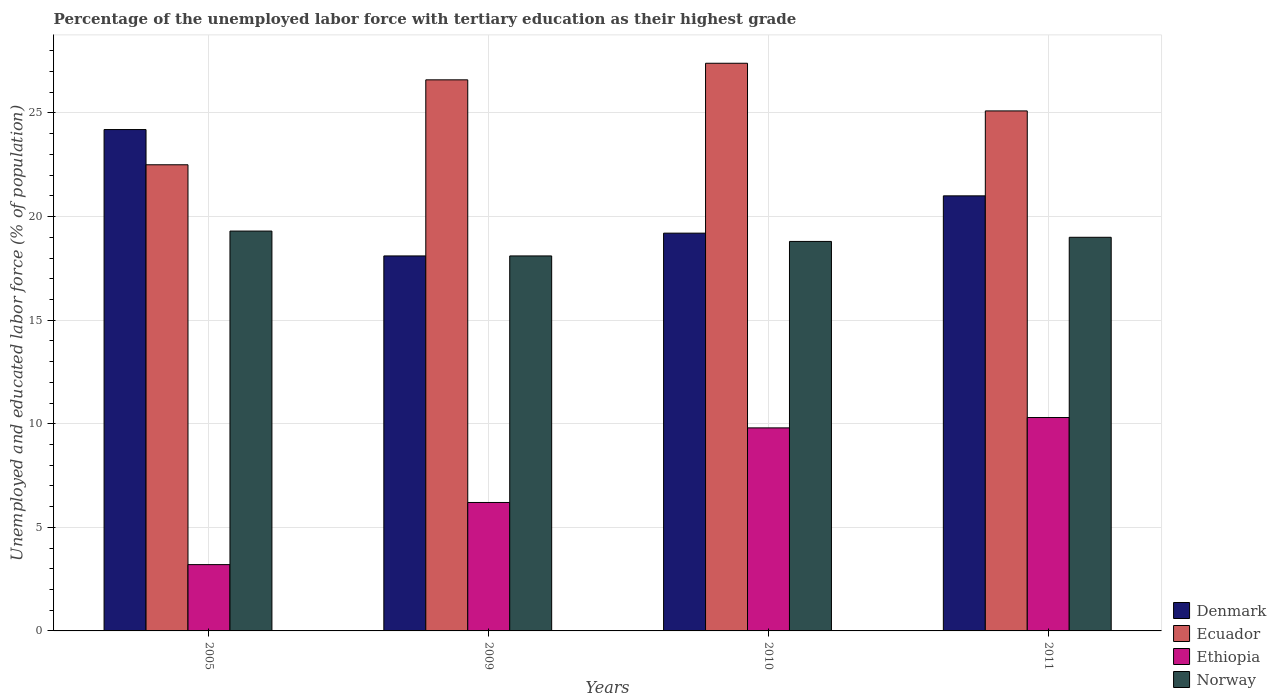How many groups of bars are there?
Offer a very short reply. 4. Are the number of bars on each tick of the X-axis equal?
Keep it short and to the point. Yes. How many bars are there on the 3rd tick from the right?
Your answer should be very brief. 4. What is the percentage of the unemployed labor force with tertiary education in Denmark in 2005?
Offer a terse response. 24.2. Across all years, what is the maximum percentage of the unemployed labor force with tertiary education in Ecuador?
Provide a short and direct response. 27.4. Across all years, what is the minimum percentage of the unemployed labor force with tertiary education in Norway?
Offer a terse response. 18.1. In which year was the percentage of the unemployed labor force with tertiary education in Norway minimum?
Your answer should be very brief. 2009. What is the total percentage of the unemployed labor force with tertiary education in Denmark in the graph?
Ensure brevity in your answer.  82.5. What is the difference between the percentage of the unemployed labor force with tertiary education in Ecuador in 2010 and the percentage of the unemployed labor force with tertiary education in Ethiopia in 2009?
Your answer should be compact. 21.2. What is the average percentage of the unemployed labor force with tertiary education in Ethiopia per year?
Provide a short and direct response. 7.38. In the year 2005, what is the difference between the percentage of the unemployed labor force with tertiary education in Denmark and percentage of the unemployed labor force with tertiary education in Ethiopia?
Provide a short and direct response. 21. What is the ratio of the percentage of the unemployed labor force with tertiary education in Ethiopia in 2010 to that in 2011?
Your answer should be very brief. 0.95. Is the difference between the percentage of the unemployed labor force with tertiary education in Denmark in 2010 and 2011 greater than the difference between the percentage of the unemployed labor force with tertiary education in Ethiopia in 2010 and 2011?
Keep it short and to the point. No. What is the difference between the highest and the second highest percentage of the unemployed labor force with tertiary education in Ethiopia?
Keep it short and to the point. 0.5. What is the difference between the highest and the lowest percentage of the unemployed labor force with tertiary education in Ecuador?
Make the answer very short. 4.9. What does the 2nd bar from the left in 2010 represents?
Give a very brief answer. Ecuador. What does the 3rd bar from the right in 2011 represents?
Make the answer very short. Ecuador. Is it the case that in every year, the sum of the percentage of the unemployed labor force with tertiary education in Denmark and percentage of the unemployed labor force with tertiary education in Norway is greater than the percentage of the unemployed labor force with tertiary education in Ethiopia?
Provide a short and direct response. Yes. How many bars are there?
Provide a short and direct response. 16. Are all the bars in the graph horizontal?
Your answer should be compact. No. How many years are there in the graph?
Provide a succinct answer. 4. What is the difference between two consecutive major ticks on the Y-axis?
Ensure brevity in your answer.  5. Are the values on the major ticks of Y-axis written in scientific E-notation?
Provide a succinct answer. No. Does the graph contain grids?
Offer a very short reply. Yes. Where does the legend appear in the graph?
Ensure brevity in your answer.  Bottom right. How many legend labels are there?
Offer a very short reply. 4. What is the title of the graph?
Make the answer very short. Percentage of the unemployed labor force with tertiary education as their highest grade. What is the label or title of the X-axis?
Make the answer very short. Years. What is the label or title of the Y-axis?
Your response must be concise. Unemployed and educated labor force (% of population). What is the Unemployed and educated labor force (% of population) in Denmark in 2005?
Provide a succinct answer. 24.2. What is the Unemployed and educated labor force (% of population) of Ecuador in 2005?
Offer a very short reply. 22.5. What is the Unemployed and educated labor force (% of population) of Ethiopia in 2005?
Your answer should be very brief. 3.2. What is the Unemployed and educated labor force (% of population) of Norway in 2005?
Provide a succinct answer. 19.3. What is the Unemployed and educated labor force (% of population) of Denmark in 2009?
Make the answer very short. 18.1. What is the Unemployed and educated labor force (% of population) in Ecuador in 2009?
Give a very brief answer. 26.6. What is the Unemployed and educated labor force (% of population) in Ethiopia in 2009?
Offer a very short reply. 6.2. What is the Unemployed and educated labor force (% of population) in Norway in 2009?
Offer a very short reply. 18.1. What is the Unemployed and educated labor force (% of population) of Denmark in 2010?
Offer a very short reply. 19.2. What is the Unemployed and educated labor force (% of population) of Ecuador in 2010?
Offer a very short reply. 27.4. What is the Unemployed and educated labor force (% of population) of Ethiopia in 2010?
Provide a short and direct response. 9.8. What is the Unemployed and educated labor force (% of population) of Norway in 2010?
Provide a succinct answer. 18.8. What is the Unemployed and educated labor force (% of population) in Denmark in 2011?
Offer a terse response. 21. What is the Unemployed and educated labor force (% of population) of Ecuador in 2011?
Provide a succinct answer. 25.1. What is the Unemployed and educated labor force (% of population) of Ethiopia in 2011?
Ensure brevity in your answer.  10.3. What is the Unemployed and educated labor force (% of population) of Norway in 2011?
Make the answer very short. 19. Across all years, what is the maximum Unemployed and educated labor force (% of population) in Denmark?
Your answer should be compact. 24.2. Across all years, what is the maximum Unemployed and educated labor force (% of population) of Ecuador?
Offer a very short reply. 27.4. Across all years, what is the maximum Unemployed and educated labor force (% of population) in Ethiopia?
Make the answer very short. 10.3. Across all years, what is the maximum Unemployed and educated labor force (% of population) in Norway?
Ensure brevity in your answer.  19.3. Across all years, what is the minimum Unemployed and educated labor force (% of population) in Denmark?
Ensure brevity in your answer.  18.1. Across all years, what is the minimum Unemployed and educated labor force (% of population) in Ethiopia?
Offer a terse response. 3.2. Across all years, what is the minimum Unemployed and educated labor force (% of population) in Norway?
Offer a very short reply. 18.1. What is the total Unemployed and educated labor force (% of population) of Denmark in the graph?
Provide a succinct answer. 82.5. What is the total Unemployed and educated labor force (% of population) of Ecuador in the graph?
Ensure brevity in your answer.  101.6. What is the total Unemployed and educated labor force (% of population) of Ethiopia in the graph?
Give a very brief answer. 29.5. What is the total Unemployed and educated labor force (% of population) in Norway in the graph?
Make the answer very short. 75.2. What is the difference between the Unemployed and educated labor force (% of population) of Ecuador in 2005 and that in 2009?
Provide a short and direct response. -4.1. What is the difference between the Unemployed and educated labor force (% of population) in Ethiopia in 2005 and that in 2009?
Ensure brevity in your answer.  -3. What is the difference between the Unemployed and educated labor force (% of population) of Denmark in 2005 and that in 2010?
Keep it short and to the point. 5. What is the difference between the Unemployed and educated labor force (% of population) of Ecuador in 2005 and that in 2010?
Your answer should be compact. -4.9. What is the difference between the Unemployed and educated labor force (% of population) in Denmark in 2005 and that in 2011?
Your answer should be very brief. 3.2. What is the difference between the Unemployed and educated labor force (% of population) in Ecuador in 2005 and that in 2011?
Provide a short and direct response. -2.6. What is the difference between the Unemployed and educated labor force (% of population) of Ethiopia in 2005 and that in 2011?
Your response must be concise. -7.1. What is the difference between the Unemployed and educated labor force (% of population) of Ecuador in 2009 and that in 2010?
Your answer should be very brief. -0.8. What is the difference between the Unemployed and educated labor force (% of population) in Ethiopia in 2009 and that in 2011?
Offer a very short reply. -4.1. What is the difference between the Unemployed and educated labor force (% of population) in Denmark in 2010 and that in 2011?
Your answer should be very brief. -1.8. What is the difference between the Unemployed and educated labor force (% of population) of Norway in 2010 and that in 2011?
Ensure brevity in your answer.  -0.2. What is the difference between the Unemployed and educated labor force (% of population) of Denmark in 2005 and the Unemployed and educated labor force (% of population) of Ethiopia in 2009?
Your response must be concise. 18. What is the difference between the Unemployed and educated labor force (% of population) in Ecuador in 2005 and the Unemployed and educated labor force (% of population) in Ethiopia in 2009?
Provide a short and direct response. 16.3. What is the difference between the Unemployed and educated labor force (% of population) in Ecuador in 2005 and the Unemployed and educated labor force (% of population) in Norway in 2009?
Your answer should be very brief. 4.4. What is the difference between the Unemployed and educated labor force (% of population) of Ethiopia in 2005 and the Unemployed and educated labor force (% of population) of Norway in 2009?
Keep it short and to the point. -14.9. What is the difference between the Unemployed and educated labor force (% of population) of Denmark in 2005 and the Unemployed and educated labor force (% of population) of Norway in 2010?
Provide a short and direct response. 5.4. What is the difference between the Unemployed and educated labor force (% of population) of Ecuador in 2005 and the Unemployed and educated labor force (% of population) of Norway in 2010?
Provide a short and direct response. 3.7. What is the difference between the Unemployed and educated labor force (% of population) of Ethiopia in 2005 and the Unemployed and educated labor force (% of population) of Norway in 2010?
Your answer should be very brief. -15.6. What is the difference between the Unemployed and educated labor force (% of population) in Denmark in 2005 and the Unemployed and educated labor force (% of population) in Ethiopia in 2011?
Your answer should be very brief. 13.9. What is the difference between the Unemployed and educated labor force (% of population) in Ecuador in 2005 and the Unemployed and educated labor force (% of population) in Ethiopia in 2011?
Your answer should be compact. 12.2. What is the difference between the Unemployed and educated labor force (% of population) of Ecuador in 2005 and the Unemployed and educated labor force (% of population) of Norway in 2011?
Give a very brief answer. 3.5. What is the difference between the Unemployed and educated labor force (% of population) of Ethiopia in 2005 and the Unemployed and educated labor force (% of population) of Norway in 2011?
Make the answer very short. -15.8. What is the difference between the Unemployed and educated labor force (% of population) of Denmark in 2009 and the Unemployed and educated labor force (% of population) of Ecuador in 2010?
Provide a succinct answer. -9.3. What is the difference between the Unemployed and educated labor force (% of population) of Denmark in 2009 and the Unemployed and educated labor force (% of population) of Norway in 2010?
Make the answer very short. -0.7. What is the difference between the Unemployed and educated labor force (% of population) of Ecuador in 2009 and the Unemployed and educated labor force (% of population) of Norway in 2010?
Your answer should be very brief. 7.8. What is the difference between the Unemployed and educated labor force (% of population) of Ethiopia in 2009 and the Unemployed and educated labor force (% of population) of Norway in 2010?
Offer a very short reply. -12.6. What is the difference between the Unemployed and educated labor force (% of population) of Denmark in 2009 and the Unemployed and educated labor force (% of population) of Ethiopia in 2011?
Offer a very short reply. 7.8. What is the difference between the Unemployed and educated labor force (% of population) in Ecuador in 2009 and the Unemployed and educated labor force (% of population) in Ethiopia in 2011?
Offer a terse response. 16.3. What is the difference between the Unemployed and educated labor force (% of population) of Ethiopia in 2009 and the Unemployed and educated labor force (% of population) of Norway in 2011?
Your answer should be compact. -12.8. What is the difference between the Unemployed and educated labor force (% of population) of Ecuador in 2010 and the Unemployed and educated labor force (% of population) of Ethiopia in 2011?
Keep it short and to the point. 17.1. What is the difference between the Unemployed and educated labor force (% of population) in Ecuador in 2010 and the Unemployed and educated labor force (% of population) in Norway in 2011?
Provide a succinct answer. 8.4. What is the average Unemployed and educated labor force (% of population) in Denmark per year?
Provide a short and direct response. 20.62. What is the average Unemployed and educated labor force (% of population) in Ecuador per year?
Your answer should be very brief. 25.4. What is the average Unemployed and educated labor force (% of population) of Ethiopia per year?
Keep it short and to the point. 7.38. In the year 2005, what is the difference between the Unemployed and educated labor force (% of population) in Denmark and Unemployed and educated labor force (% of population) in Ecuador?
Offer a very short reply. 1.7. In the year 2005, what is the difference between the Unemployed and educated labor force (% of population) of Denmark and Unemployed and educated labor force (% of population) of Ethiopia?
Your answer should be very brief. 21. In the year 2005, what is the difference between the Unemployed and educated labor force (% of population) of Ecuador and Unemployed and educated labor force (% of population) of Ethiopia?
Provide a short and direct response. 19.3. In the year 2005, what is the difference between the Unemployed and educated labor force (% of population) in Ethiopia and Unemployed and educated labor force (% of population) in Norway?
Keep it short and to the point. -16.1. In the year 2009, what is the difference between the Unemployed and educated labor force (% of population) in Denmark and Unemployed and educated labor force (% of population) in Ethiopia?
Offer a very short reply. 11.9. In the year 2009, what is the difference between the Unemployed and educated labor force (% of population) of Denmark and Unemployed and educated labor force (% of population) of Norway?
Give a very brief answer. 0. In the year 2009, what is the difference between the Unemployed and educated labor force (% of population) in Ecuador and Unemployed and educated labor force (% of population) in Ethiopia?
Offer a terse response. 20.4. In the year 2009, what is the difference between the Unemployed and educated labor force (% of population) in Ecuador and Unemployed and educated labor force (% of population) in Norway?
Ensure brevity in your answer.  8.5. In the year 2010, what is the difference between the Unemployed and educated labor force (% of population) in Denmark and Unemployed and educated labor force (% of population) in Ecuador?
Ensure brevity in your answer.  -8.2. In the year 2010, what is the difference between the Unemployed and educated labor force (% of population) in Denmark and Unemployed and educated labor force (% of population) in Ethiopia?
Give a very brief answer. 9.4. In the year 2010, what is the difference between the Unemployed and educated labor force (% of population) in Denmark and Unemployed and educated labor force (% of population) in Norway?
Keep it short and to the point. 0.4. In the year 2010, what is the difference between the Unemployed and educated labor force (% of population) of Ecuador and Unemployed and educated labor force (% of population) of Ethiopia?
Offer a very short reply. 17.6. In the year 2010, what is the difference between the Unemployed and educated labor force (% of population) in Ecuador and Unemployed and educated labor force (% of population) in Norway?
Ensure brevity in your answer.  8.6. In the year 2010, what is the difference between the Unemployed and educated labor force (% of population) of Ethiopia and Unemployed and educated labor force (% of population) of Norway?
Your response must be concise. -9. In the year 2011, what is the difference between the Unemployed and educated labor force (% of population) of Denmark and Unemployed and educated labor force (% of population) of Norway?
Offer a very short reply. 2. What is the ratio of the Unemployed and educated labor force (% of population) of Denmark in 2005 to that in 2009?
Keep it short and to the point. 1.34. What is the ratio of the Unemployed and educated labor force (% of population) of Ecuador in 2005 to that in 2009?
Give a very brief answer. 0.85. What is the ratio of the Unemployed and educated labor force (% of population) in Ethiopia in 2005 to that in 2009?
Keep it short and to the point. 0.52. What is the ratio of the Unemployed and educated labor force (% of population) of Norway in 2005 to that in 2009?
Your answer should be compact. 1.07. What is the ratio of the Unemployed and educated labor force (% of population) of Denmark in 2005 to that in 2010?
Give a very brief answer. 1.26. What is the ratio of the Unemployed and educated labor force (% of population) of Ecuador in 2005 to that in 2010?
Ensure brevity in your answer.  0.82. What is the ratio of the Unemployed and educated labor force (% of population) of Ethiopia in 2005 to that in 2010?
Offer a very short reply. 0.33. What is the ratio of the Unemployed and educated labor force (% of population) in Norway in 2005 to that in 2010?
Offer a very short reply. 1.03. What is the ratio of the Unemployed and educated labor force (% of population) in Denmark in 2005 to that in 2011?
Make the answer very short. 1.15. What is the ratio of the Unemployed and educated labor force (% of population) of Ecuador in 2005 to that in 2011?
Ensure brevity in your answer.  0.9. What is the ratio of the Unemployed and educated labor force (% of population) in Ethiopia in 2005 to that in 2011?
Keep it short and to the point. 0.31. What is the ratio of the Unemployed and educated labor force (% of population) of Norway in 2005 to that in 2011?
Provide a succinct answer. 1.02. What is the ratio of the Unemployed and educated labor force (% of population) of Denmark in 2009 to that in 2010?
Ensure brevity in your answer.  0.94. What is the ratio of the Unemployed and educated labor force (% of population) in Ecuador in 2009 to that in 2010?
Keep it short and to the point. 0.97. What is the ratio of the Unemployed and educated labor force (% of population) of Ethiopia in 2009 to that in 2010?
Your answer should be compact. 0.63. What is the ratio of the Unemployed and educated labor force (% of population) in Norway in 2009 to that in 2010?
Your answer should be very brief. 0.96. What is the ratio of the Unemployed and educated labor force (% of population) in Denmark in 2009 to that in 2011?
Make the answer very short. 0.86. What is the ratio of the Unemployed and educated labor force (% of population) in Ecuador in 2009 to that in 2011?
Keep it short and to the point. 1.06. What is the ratio of the Unemployed and educated labor force (% of population) in Ethiopia in 2009 to that in 2011?
Provide a short and direct response. 0.6. What is the ratio of the Unemployed and educated labor force (% of population) of Norway in 2009 to that in 2011?
Provide a short and direct response. 0.95. What is the ratio of the Unemployed and educated labor force (% of population) of Denmark in 2010 to that in 2011?
Your answer should be compact. 0.91. What is the ratio of the Unemployed and educated labor force (% of population) of Ecuador in 2010 to that in 2011?
Provide a succinct answer. 1.09. What is the ratio of the Unemployed and educated labor force (% of population) of Ethiopia in 2010 to that in 2011?
Offer a terse response. 0.95. What is the difference between the highest and the second highest Unemployed and educated labor force (% of population) of Ethiopia?
Your answer should be compact. 0.5. What is the difference between the highest and the second highest Unemployed and educated labor force (% of population) in Norway?
Keep it short and to the point. 0.3. What is the difference between the highest and the lowest Unemployed and educated labor force (% of population) of Ecuador?
Your answer should be compact. 4.9. 